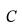<formula> <loc_0><loc_0><loc_500><loc_500>C</formula> 